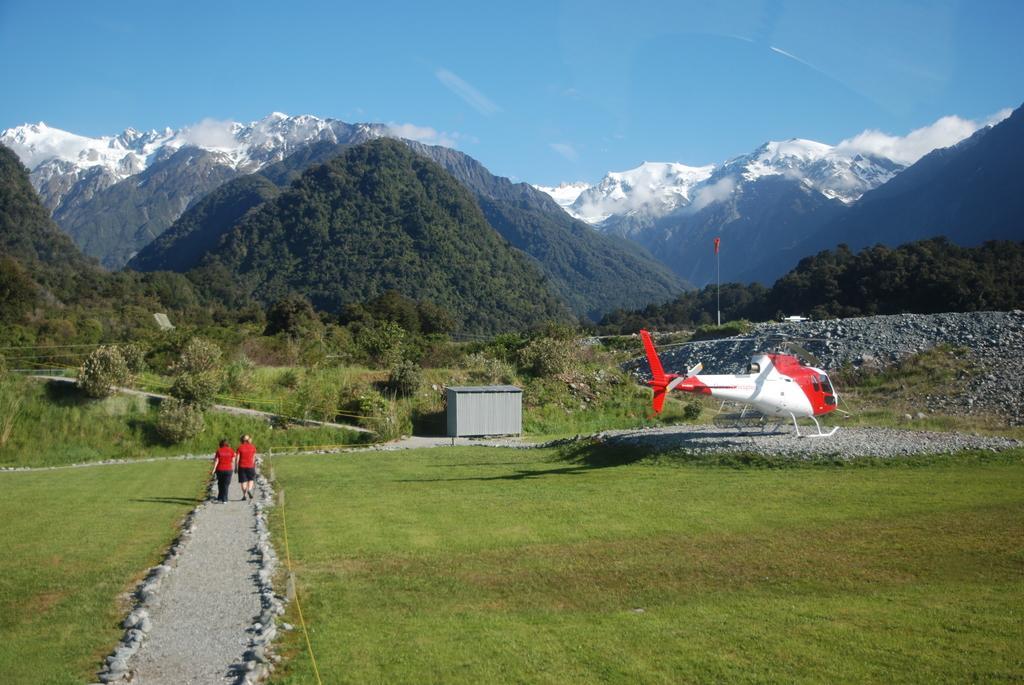How would you summarize this image in a sentence or two? In this picture there are two people walking on path and we can see grass, airplane, shed, trees, stones and hills. In the background of the image we can see the sky. 